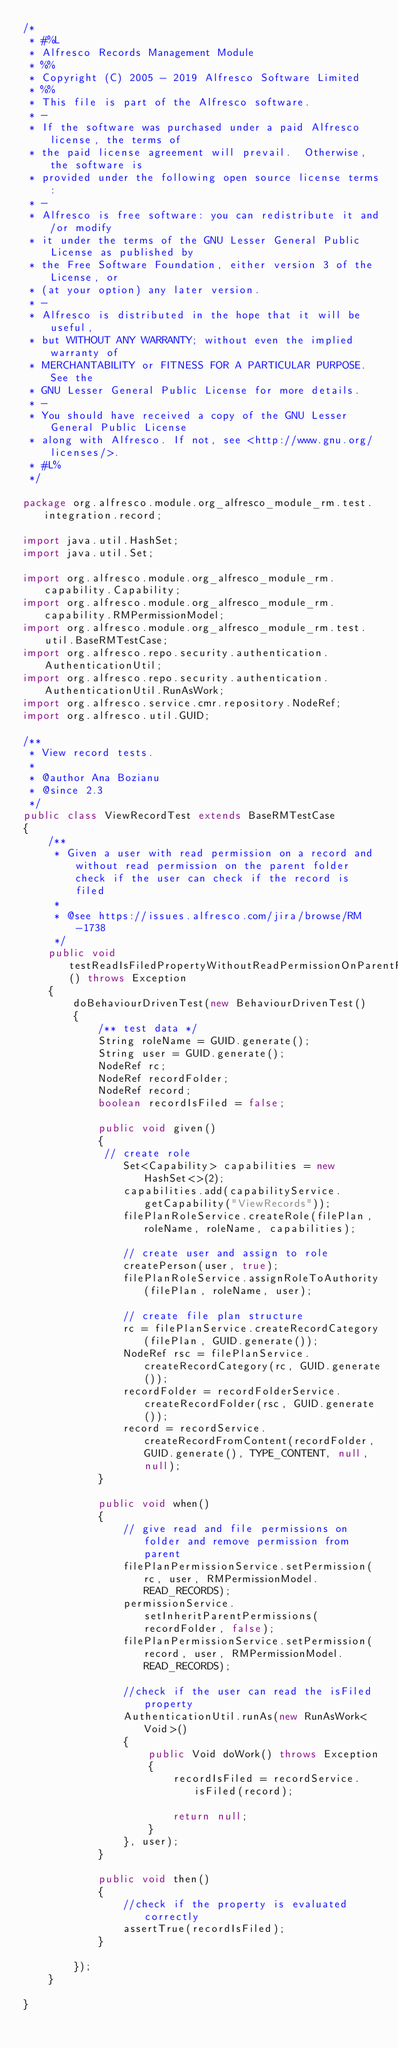Convert code to text. <code><loc_0><loc_0><loc_500><loc_500><_Java_>/*
 * #%L
 * Alfresco Records Management Module
 * %%
 * Copyright (C) 2005 - 2019 Alfresco Software Limited
 * %%
 * This file is part of the Alfresco software.
 * -
 * If the software was purchased under a paid Alfresco license, the terms of
 * the paid license agreement will prevail.  Otherwise, the software is
 * provided under the following open source license terms:
 * -
 * Alfresco is free software: you can redistribute it and/or modify
 * it under the terms of the GNU Lesser General Public License as published by
 * the Free Software Foundation, either version 3 of the License, or
 * (at your option) any later version.
 * -
 * Alfresco is distributed in the hope that it will be useful,
 * but WITHOUT ANY WARRANTY; without even the implied warranty of
 * MERCHANTABILITY or FITNESS FOR A PARTICULAR PURPOSE.  See the
 * GNU Lesser General Public License for more details.
 * -
 * You should have received a copy of the GNU Lesser General Public License
 * along with Alfresco. If not, see <http://www.gnu.org/licenses/>.
 * #L%
 */

package org.alfresco.module.org_alfresco_module_rm.test.integration.record;

import java.util.HashSet;
import java.util.Set;

import org.alfresco.module.org_alfresco_module_rm.capability.Capability;
import org.alfresco.module.org_alfresco_module_rm.capability.RMPermissionModel;
import org.alfresco.module.org_alfresco_module_rm.test.util.BaseRMTestCase;
import org.alfresco.repo.security.authentication.AuthenticationUtil;
import org.alfresco.repo.security.authentication.AuthenticationUtil.RunAsWork;
import org.alfresco.service.cmr.repository.NodeRef;
import org.alfresco.util.GUID;

/**
 * View record tests.
 *
 * @author Ana Bozianu
 * @since 2.3
 */
public class ViewRecordTest extends BaseRMTestCase
{
    /**
     * Given a user with read permission on a record and without read permission on the parent folder check if the user can check if the record is filed
     *
     * @see https://issues.alfresco.com/jira/browse/RM-1738
     */
    public void testReadIsFiledPropertyWithoutReadPermissionOnParentFolder() throws Exception
    {
        doBehaviourDrivenTest(new BehaviourDrivenTest()
        {
            /** test data */
            String roleName = GUID.generate();
            String user = GUID.generate();
            NodeRef rc;
            NodeRef recordFolder;
            NodeRef record;
            boolean recordIsFiled = false;

            public void given()
            {
             // create role
                Set<Capability> capabilities = new HashSet<>(2);
                capabilities.add(capabilityService.getCapability("ViewRecords"));
                filePlanRoleService.createRole(filePlan, roleName, roleName, capabilities);

                // create user and assign to role
                createPerson(user, true);
                filePlanRoleService.assignRoleToAuthority(filePlan, roleName, user);

                // create file plan structure
                rc = filePlanService.createRecordCategory(filePlan, GUID.generate());
                NodeRef rsc = filePlanService.createRecordCategory(rc, GUID.generate());
                recordFolder = recordFolderService.createRecordFolder(rsc, GUID.generate());
                record = recordService.createRecordFromContent(recordFolder, GUID.generate(), TYPE_CONTENT, null, null);
            }

            public void when()
            {
                // give read and file permissions on folder and remove permission from parent
                filePlanPermissionService.setPermission(rc, user, RMPermissionModel.READ_RECORDS);
                permissionService.setInheritParentPermissions(recordFolder, false);
                filePlanPermissionService.setPermission(record, user, RMPermissionModel.READ_RECORDS);

                //check if the user can read the isFiled property
                AuthenticationUtil.runAs(new RunAsWork<Void>()
                {
                    public Void doWork() throws Exception
                    {
                        recordIsFiled = recordService.isFiled(record);

                        return null;
                    }
                }, user);
            }

            public void then()
            {
                //check if the property is evaluated correctly
                assertTrue(recordIsFiled);
            }

        });
    }

}
</code> 